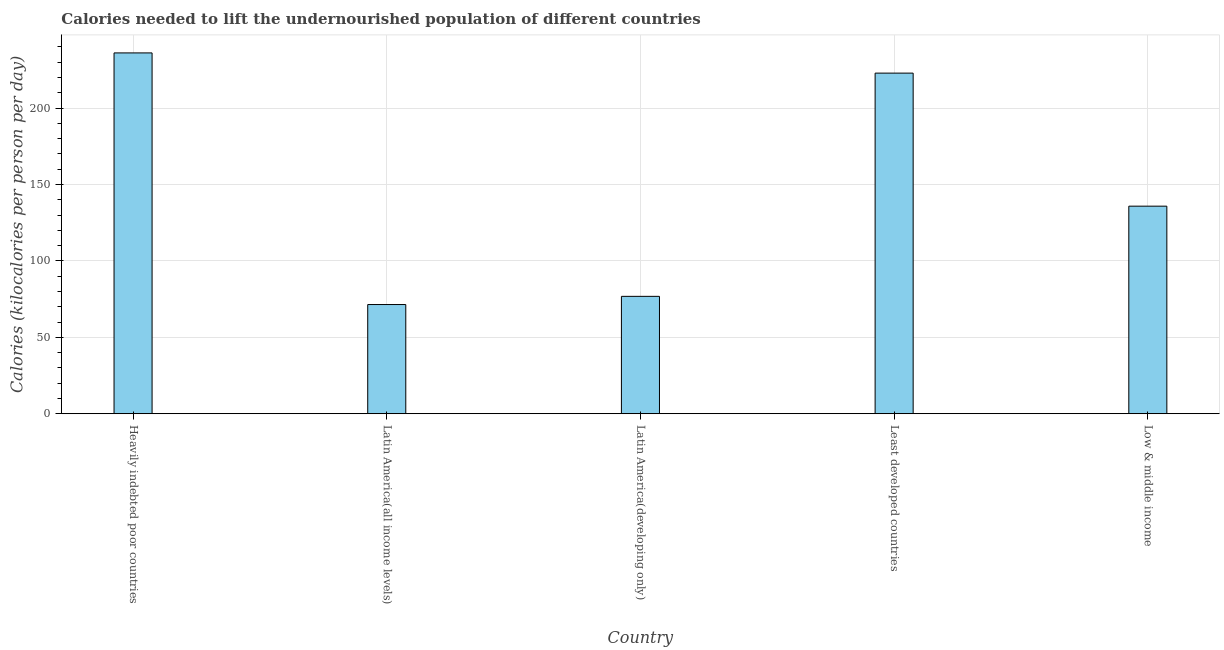Does the graph contain grids?
Make the answer very short. Yes. What is the title of the graph?
Ensure brevity in your answer.  Calories needed to lift the undernourished population of different countries. What is the label or title of the X-axis?
Ensure brevity in your answer.  Country. What is the label or title of the Y-axis?
Keep it short and to the point. Calories (kilocalories per person per day). What is the depth of food deficit in Latin America(developing only)?
Your answer should be very brief. 76.82. Across all countries, what is the maximum depth of food deficit?
Your answer should be very brief. 236.12. Across all countries, what is the minimum depth of food deficit?
Your answer should be very brief. 71.46. In which country was the depth of food deficit maximum?
Give a very brief answer. Heavily indebted poor countries. In which country was the depth of food deficit minimum?
Your response must be concise. Latin America(all income levels). What is the sum of the depth of food deficit?
Give a very brief answer. 743.14. What is the difference between the depth of food deficit in Latin America(developing only) and Low & middle income?
Ensure brevity in your answer.  -59.02. What is the average depth of food deficit per country?
Provide a short and direct response. 148.63. What is the median depth of food deficit?
Keep it short and to the point. 135.84. In how many countries, is the depth of food deficit greater than 70 kilocalories?
Your response must be concise. 5. What is the ratio of the depth of food deficit in Heavily indebted poor countries to that in Latin America(developing only)?
Offer a very short reply. 3.07. Is the depth of food deficit in Heavily indebted poor countries less than that in Latin America(all income levels)?
Your answer should be compact. No. Is the difference between the depth of food deficit in Least developed countries and Low & middle income greater than the difference between any two countries?
Your answer should be compact. No. What is the difference between the highest and the second highest depth of food deficit?
Give a very brief answer. 13.22. What is the difference between the highest and the lowest depth of food deficit?
Provide a short and direct response. 164.66. In how many countries, is the depth of food deficit greater than the average depth of food deficit taken over all countries?
Offer a very short reply. 2. What is the Calories (kilocalories per person per day) of Heavily indebted poor countries?
Your response must be concise. 236.12. What is the Calories (kilocalories per person per day) in Latin America(all income levels)?
Ensure brevity in your answer.  71.46. What is the Calories (kilocalories per person per day) in Latin America(developing only)?
Ensure brevity in your answer.  76.82. What is the Calories (kilocalories per person per day) of Least developed countries?
Your answer should be compact. 222.9. What is the Calories (kilocalories per person per day) of Low & middle income?
Ensure brevity in your answer.  135.84. What is the difference between the Calories (kilocalories per person per day) in Heavily indebted poor countries and Latin America(all income levels)?
Your answer should be compact. 164.66. What is the difference between the Calories (kilocalories per person per day) in Heavily indebted poor countries and Latin America(developing only)?
Offer a very short reply. 159.3. What is the difference between the Calories (kilocalories per person per day) in Heavily indebted poor countries and Least developed countries?
Give a very brief answer. 13.22. What is the difference between the Calories (kilocalories per person per day) in Heavily indebted poor countries and Low & middle income?
Give a very brief answer. 100.28. What is the difference between the Calories (kilocalories per person per day) in Latin America(all income levels) and Latin America(developing only)?
Your response must be concise. -5.36. What is the difference between the Calories (kilocalories per person per day) in Latin America(all income levels) and Least developed countries?
Your answer should be compact. -151.45. What is the difference between the Calories (kilocalories per person per day) in Latin America(all income levels) and Low & middle income?
Your answer should be compact. -64.38. What is the difference between the Calories (kilocalories per person per day) in Latin America(developing only) and Least developed countries?
Your response must be concise. -146.09. What is the difference between the Calories (kilocalories per person per day) in Latin America(developing only) and Low & middle income?
Give a very brief answer. -59.02. What is the difference between the Calories (kilocalories per person per day) in Least developed countries and Low & middle income?
Your response must be concise. 87.07. What is the ratio of the Calories (kilocalories per person per day) in Heavily indebted poor countries to that in Latin America(all income levels)?
Your response must be concise. 3.3. What is the ratio of the Calories (kilocalories per person per day) in Heavily indebted poor countries to that in Latin America(developing only)?
Offer a terse response. 3.07. What is the ratio of the Calories (kilocalories per person per day) in Heavily indebted poor countries to that in Least developed countries?
Keep it short and to the point. 1.06. What is the ratio of the Calories (kilocalories per person per day) in Heavily indebted poor countries to that in Low & middle income?
Offer a terse response. 1.74. What is the ratio of the Calories (kilocalories per person per day) in Latin America(all income levels) to that in Least developed countries?
Provide a short and direct response. 0.32. What is the ratio of the Calories (kilocalories per person per day) in Latin America(all income levels) to that in Low & middle income?
Your response must be concise. 0.53. What is the ratio of the Calories (kilocalories per person per day) in Latin America(developing only) to that in Least developed countries?
Your response must be concise. 0.34. What is the ratio of the Calories (kilocalories per person per day) in Latin America(developing only) to that in Low & middle income?
Your answer should be very brief. 0.57. What is the ratio of the Calories (kilocalories per person per day) in Least developed countries to that in Low & middle income?
Offer a very short reply. 1.64. 